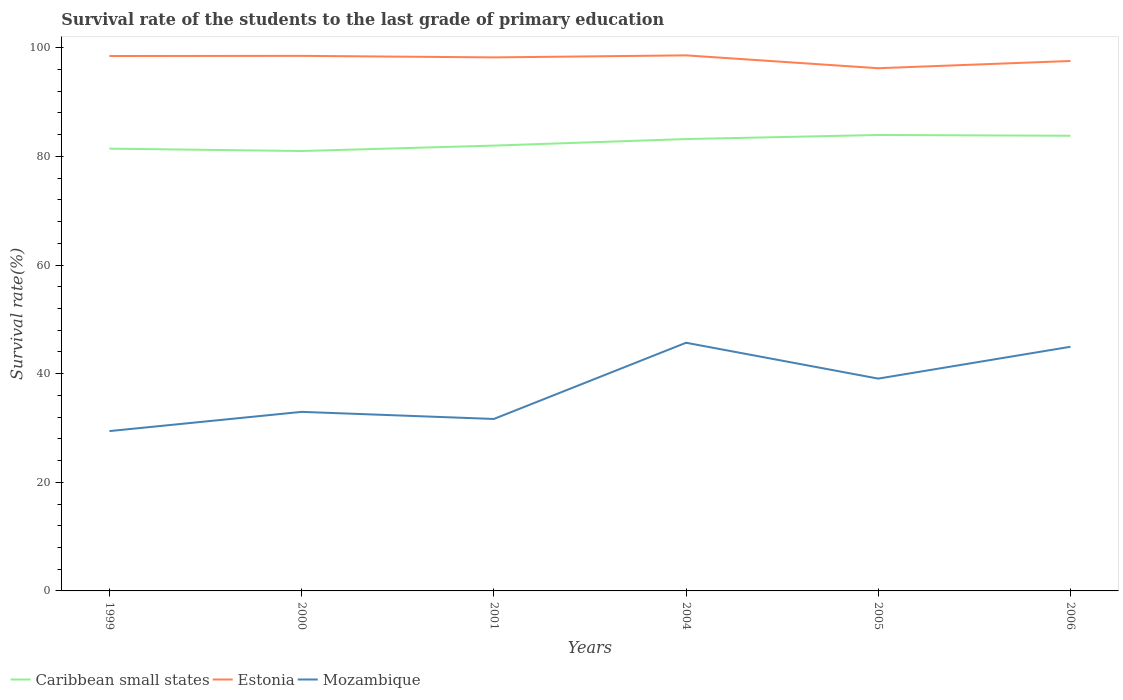How many different coloured lines are there?
Your response must be concise. 3. Is the number of lines equal to the number of legend labels?
Offer a very short reply. Yes. Across all years, what is the maximum survival rate of the students in Mozambique?
Your answer should be very brief. 29.43. In which year was the survival rate of the students in Estonia maximum?
Your answer should be very brief. 2005. What is the total survival rate of the students in Mozambique in the graph?
Your answer should be very brief. -3.54. What is the difference between the highest and the second highest survival rate of the students in Caribbean small states?
Offer a terse response. 2.95. What is the difference between the highest and the lowest survival rate of the students in Estonia?
Your response must be concise. 4. How many years are there in the graph?
Make the answer very short. 6. What is the difference between two consecutive major ticks on the Y-axis?
Your response must be concise. 20. Where does the legend appear in the graph?
Make the answer very short. Bottom left. How are the legend labels stacked?
Keep it short and to the point. Horizontal. What is the title of the graph?
Your answer should be very brief. Survival rate of the students to the last grade of primary education. Does "Turkmenistan" appear as one of the legend labels in the graph?
Your answer should be very brief. No. What is the label or title of the X-axis?
Your answer should be very brief. Years. What is the label or title of the Y-axis?
Your response must be concise. Survival rate(%). What is the Survival rate(%) of Caribbean small states in 1999?
Give a very brief answer. 81.43. What is the Survival rate(%) in Estonia in 1999?
Offer a terse response. 98.48. What is the Survival rate(%) in Mozambique in 1999?
Provide a short and direct response. 29.43. What is the Survival rate(%) in Caribbean small states in 2000?
Offer a very short reply. 80.99. What is the Survival rate(%) in Estonia in 2000?
Your answer should be very brief. 98.51. What is the Survival rate(%) in Mozambique in 2000?
Offer a very short reply. 32.97. What is the Survival rate(%) in Caribbean small states in 2001?
Your response must be concise. 81.99. What is the Survival rate(%) of Estonia in 2001?
Ensure brevity in your answer.  98.23. What is the Survival rate(%) of Mozambique in 2001?
Your response must be concise. 31.66. What is the Survival rate(%) of Caribbean small states in 2004?
Keep it short and to the point. 83.19. What is the Survival rate(%) of Estonia in 2004?
Provide a short and direct response. 98.6. What is the Survival rate(%) in Mozambique in 2004?
Your answer should be very brief. 45.69. What is the Survival rate(%) of Caribbean small states in 2005?
Your answer should be compact. 83.94. What is the Survival rate(%) of Estonia in 2005?
Give a very brief answer. 96.24. What is the Survival rate(%) in Mozambique in 2005?
Provide a succinct answer. 39.09. What is the Survival rate(%) in Caribbean small states in 2006?
Provide a succinct answer. 83.8. What is the Survival rate(%) in Estonia in 2006?
Provide a succinct answer. 97.57. What is the Survival rate(%) of Mozambique in 2006?
Offer a very short reply. 44.95. Across all years, what is the maximum Survival rate(%) of Caribbean small states?
Your answer should be very brief. 83.94. Across all years, what is the maximum Survival rate(%) of Estonia?
Give a very brief answer. 98.6. Across all years, what is the maximum Survival rate(%) in Mozambique?
Keep it short and to the point. 45.69. Across all years, what is the minimum Survival rate(%) in Caribbean small states?
Your response must be concise. 80.99. Across all years, what is the minimum Survival rate(%) in Estonia?
Make the answer very short. 96.24. Across all years, what is the minimum Survival rate(%) in Mozambique?
Ensure brevity in your answer.  29.43. What is the total Survival rate(%) in Caribbean small states in the graph?
Your answer should be very brief. 495.35. What is the total Survival rate(%) of Estonia in the graph?
Your answer should be compact. 587.63. What is the total Survival rate(%) of Mozambique in the graph?
Your answer should be very brief. 223.79. What is the difference between the Survival rate(%) in Caribbean small states in 1999 and that in 2000?
Give a very brief answer. 0.44. What is the difference between the Survival rate(%) of Estonia in 1999 and that in 2000?
Keep it short and to the point. -0.03. What is the difference between the Survival rate(%) in Mozambique in 1999 and that in 2000?
Provide a succinct answer. -3.54. What is the difference between the Survival rate(%) of Caribbean small states in 1999 and that in 2001?
Keep it short and to the point. -0.56. What is the difference between the Survival rate(%) in Estonia in 1999 and that in 2001?
Your answer should be very brief. 0.25. What is the difference between the Survival rate(%) of Mozambique in 1999 and that in 2001?
Offer a very short reply. -2.23. What is the difference between the Survival rate(%) of Caribbean small states in 1999 and that in 2004?
Your response must be concise. -1.76. What is the difference between the Survival rate(%) of Estonia in 1999 and that in 2004?
Offer a very short reply. -0.12. What is the difference between the Survival rate(%) of Mozambique in 1999 and that in 2004?
Offer a terse response. -16.26. What is the difference between the Survival rate(%) of Caribbean small states in 1999 and that in 2005?
Your answer should be compact. -2.51. What is the difference between the Survival rate(%) of Estonia in 1999 and that in 2005?
Make the answer very short. 2.25. What is the difference between the Survival rate(%) of Mozambique in 1999 and that in 2005?
Provide a succinct answer. -9.66. What is the difference between the Survival rate(%) in Caribbean small states in 1999 and that in 2006?
Offer a terse response. -2.37. What is the difference between the Survival rate(%) in Estonia in 1999 and that in 2006?
Offer a very short reply. 0.91. What is the difference between the Survival rate(%) in Mozambique in 1999 and that in 2006?
Your response must be concise. -15.52. What is the difference between the Survival rate(%) in Caribbean small states in 2000 and that in 2001?
Keep it short and to the point. -1. What is the difference between the Survival rate(%) of Estonia in 2000 and that in 2001?
Your answer should be very brief. 0.28. What is the difference between the Survival rate(%) in Mozambique in 2000 and that in 2001?
Your answer should be very brief. 1.31. What is the difference between the Survival rate(%) in Caribbean small states in 2000 and that in 2004?
Offer a terse response. -2.2. What is the difference between the Survival rate(%) in Estonia in 2000 and that in 2004?
Provide a succinct answer. -0.09. What is the difference between the Survival rate(%) in Mozambique in 2000 and that in 2004?
Offer a terse response. -12.72. What is the difference between the Survival rate(%) in Caribbean small states in 2000 and that in 2005?
Keep it short and to the point. -2.95. What is the difference between the Survival rate(%) of Estonia in 2000 and that in 2005?
Your response must be concise. 2.28. What is the difference between the Survival rate(%) of Mozambique in 2000 and that in 2005?
Your answer should be compact. -6.12. What is the difference between the Survival rate(%) of Caribbean small states in 2000 and that in 2006?
Your answer should be compact. -2.81. What is the difference between the Survival rate(%) of Estonia in 2000 and that in 2006?
Make the answer very short. 0.94. What is the difference between the Survival rate(%) in Mozambique in 2000 and that in 2006?
Offer a terse response. -11.98. What is the difference between the Survival rate(%) in Caribbean small states in 2001 and that in 2004?
Your response must be concise. -1.2. What is the difference between the Survival rate(%) in Estonia in 2001 and that in 2004?
Make the answer very short. -0.37. What is the difference between the Survival rate(%) in Mozambique in 2001 and that in 2004?
Provide a short and direct response. -14.03. What is the difference between the Survival rate(%) in Caribbean small states in 2001 and that in 2005?
Give a very brief answer. -1.95. What is the difference between the Survival rate(%) of Estonia in 2001 and that in 2005?
Provide a short and direct response. 1.99. What is the difference between the Survival rate(%) in Mozambique in 2001 and that in 2005?
Offer a terse response. -7.43. What is the difference between the Survival rate(%) of Caribbean small states in 2001 and that in 2006?
Offer a very short reply. -1.81. What is the difference between the Survival rate(%) in Estonia in 2001 and that in 2006?
Offer a terse response. 0.66. What is the difference between the Survival rate(%) in Mozambique in 2001 and that in 2006?
Make the answer very short. -13.29. What is the difference between the Survival rate(%) of Caribbean small states in 2004 and that in 2005?
Provide a short and direct response. -0.75. What is the difference between the Survival rate(%) in Estonia in 2004 and that in 2005?
Make the answer very short. 2.37. What is the difference between the Survival rate(%) in Mozambique in 2004 and that in 2005?
Provide a succinct answer. 6.6. What is the difference between the Survival rate(%) in Caribbean small states in 2004 and that in 2006?
Provide a succinct answer. -0.61. What is the difference between the Survival rate(%) of Estonia in 2004 and that in 2006?
Offer a very short reply. 1.03. What is the difference between the Survival rate(%) of Mozambique in 2004 and that in 2006?
Give a very brief answer. 0.74. What is the difference between the Survival rate(%) of Caribbean small states in 2005 and that in 2006?
Your response must be concise. 0.14. What is the difference between the Survival rate(%) of Estonia in 2005 and that in 2006?
Your answer should be very brief. -1.33. What is the difference between the Survival rate(%) in Mozambique in 2005 and that in 2006?
Offer a very short reply. -5.86. What is the difference between the Survival rate(%) of Caribbean small states in 1999 and the Survival rate(%) of Estonia in 2000?
Your response must be concise. -17.08. What is the difference between the Survival rate(%) of Caribbean small states in 1999 and the Survival rate(%) of Mozambique in 2000?
Give a very brief answer. 48.46. What is the difference between the Survival rate(%) of Estonia in 1999 and the Survival rate(%) of Mozambique in 2000?
Offer a terse response. 65.51. What is the difference between the Survival rate(%) in Caribbean small states in 1999 and the Survival rate(%) in Estonia in 2001?
Make the answer very short. -16.8. What is the difference between the Survival rate(%) in Caribbean small states in 1999 and the Survival rate(%) in Mozambique in 2001?
Provide a short and direct response. 49.77. What is the difference between the Survival rate(%) of Estonia in 1999 and the Survival rate(%) of Mozambique in 2001?
Your answer should be very brief. 66.82. What is the difference between the Survival rate(%) of Caribbean small states in 1999 and the Survival rate(%) of Estonia in 2004?
Your response must be concise. -17.17. What is the difference between the Survival rate(%) of Caribbean small states in 1999 and the Survival rate(%) of Mozambique in 2004?
Provide a short and direct response. 35.74. What is the difference between the Survival rate(%) in Estonia in 1999 and the Survival rate(%) in Mozambique in 2004?
Your answer should be very brief. 52.79. What is the difference between the Survival rate(%) in Caribbean small states in 1999 and the Survival rate(%) in Estonia in 2005?
Provide a succinct answer. -14.81. What is the difference between the Survival rate(%) of Caribbean small states in 1999 and the Survival rate(%) of Mozambique in 2005?
Your answer should be very brief. 42.34. What is the difference between the Survival rate(%) in Estonia in 1999 and the Survival rate(%) in Mozambique in 2005?
Offer a very short reply. 59.39. What is the difference between the Survival rate(%) of Caribbean small states in 1999 and the Survival rate(%) of Estonia in 2006?
Offer a very short reply. -16.14. What is the difference between the Survival rate(%) in Caribbean small states in 1999 and the Survival rate(%) in Mozambique in 2006?
Ensure brevity in your answer.  36.48. What is the difference between the Survival rate(%) of Estonia in 1999 and the Survival rate(%) of Mozambique in 2006?
Your response must be concise. 53.53. What is the difference between the Survival rate(%) of Caribbean small states in 2000 and the Survival rate(%) of Estonia in 2001?
Offer a terse response. -17.24. What is the difference between the Survival rate(%) of Caribbean small states in 2000 and the Survival rate(%) of Mozambique in 2001?
Ensure brevity in your answer.  49.33. What is the difference between the Survival rate(%) of Estonia in 2000 and the Survival rate(%) of Mozambique in 2001?
Offer a very short reply. 66.85. What is the difference between the Survival rate(%) of Caribbean small states in 2000 and the Survival rate(%) of Estonia in 2004?
Provide a short and direct response. -17.61. What is the difference between the Survival rate(%) of Caribbean small states in 2000 and the Survival rate(%) of Mozambique in 2004?
Your answer should be compact. 35.3. What is the difference between the Survival rate(%) in Estonia in 2000 and the Survival rate(%) in Mozambique in 2004?
Make the answer very short. 52.82. What is the difference between the Survival rate(%) of Caribbean small states in 2000 and the Survival rate(%) of Estonia in 2005?
Ensure brevity in your answer.  -15.24. What is the difference between the Survival rate(%) in Caribbean small states in 2000 and the Survival rate(%) in Mozambique in 2005?
Ensure brevity in your answer.  41.9. What is the difference between the Survival rate(%) in Estonia in 2000 and the Survival rate(%) in Mozambique in 2005?
Keep it short and to the point. 59.42. What is the difference between the Survival rate(%) in Caribbean small states in 2000 and the Survival rate(%) in Estonia in 2006?
Give a very brief answer. -16.58. What is the difference between the Survival rate(%) of Caribbean small states in 2000 and the Survival rate(%) of Mozambique in 2006?
Make the answer very short. 36.04. What is the difference between the Survival rate(%) of Estonia in 2000 and the Survival rate(%) of Mozambique in 2006?
Your answer should be very brief. 53.56. What is the difference between the Survival rate(%) of Caribbean small states in 2001 and the Survival rate(%) of Estonia in 2004?
Keep it short and to the point. -16.61. What is the difference between the Survival rate(%) of Caribbean small states in 2001 and the Survival rate(%) of Mozambique in 2004?
Your answer should be compact. 36.3. What is the difference between the Survival rate(%) of Estonia in 2001 and the Survival rate(%) of Mozambique in 2004?
Keep it short and to the point. 52.54. What is the difference between the Survival rate(%) in Caribbean small states in 2001 and the Survival rate(%) in Estonia in 2005?
Provide a short and direct response. -14.25. What is the difference between the Survival rate(%) of Caribbean small states in 2001 and the Survival rate(%) of Mozambique in 2005?
Give a very brief answer. 42.9. What is the difference between the Survival rate(%) in Estonia in 2001 and the Survival rate(%) in Mozambique in 2005?
Make the answer very short. 59.14. What is the difference between the Survival rate(%) in Caribbean small states in 2001 and the Survival rate(%) in Estonia in 2006?
Your answer should be compact. -15.58. What is the difference between the Survival rate(%) of Caribbean small states in 2001 and the Survival rate(%) of Mozambique in 2006?
Your answer should be compact. 37.04. What is the difference between the Survival rate(%) of Estonia in 2001 and the Survival rate(%) of Mozambique in 2006?
Your answer should be very brief. 53.28. What is the difference between the Survival rate(%) in Caribbean small states in 2004 and the Survival rate(%) in Estonia in 2005?
Make the answer very short. -13.04. What is the difference between the Survival rate(%) in Caribbean small states in 2004 and the Survival rate(%) in Mozambique in 2005?
Offer a terse response. 44.1. What is the difference between the Survival rate(%) in Estonia in 2004 and the Survival rate(%) in Mozambique in 2005?
Ensure brevity in your answer.  59.51. What is the difference between the Survival rate(%) of Caribbean small states in 2004 and the Survival rate(%) of Estonia in 2006?
Provide a short and direct response. -14.38. What is the difference between the Survival rate(%) in Caribbean small states in 2004 and the Survival rate(%) in Mozambique in 2006?
Give a very brief answer. 38.24. What is the difference between the Survival rate(%) in Estonia in 2004 and the Survival rate(%) in Mozambique in 2006?
Keep it short and to the point. 53.65. What is the difference between the Survival rate(%) of Caribbean small states in 2005 and the Survival rate(%) of Estonia in 2006?
Your answer should be compact. -13.63. What is the difference between the Survival rate(%) of Caribbean small states in 2005 and the Survival rate(%) of Mozambique in 2006?
Offer a very short reply. 38.99. What is the difference between the Survival rate(%) of Estonia in 2005 and the Survival rate(%) of Mozambique in 2006?
Your response must be concise. 51.29. What is the average Survival rate(%) of Caribbean small states per year?
Offer a very short reply. 82.56. What is the average Survival rate(%) in Estonia per year?
Offer a very short reply. 97.94. What is the average Survival rate(%) in Mozambique per year?
Make the answer very short. 37.3. In the year 1999, what is the difference between the Survival rate(%) of Caribbean small states and Survival rate(%) of Estonia?
Keep it short and to the point. -17.05. In the year 1999, what is the difference between the Survival rate(%) of Caribbean small states and Survival rate(%) of Mozambique?
Keep it short and to the point. 52. In the year 1999, what is the difference between the Survival rate(%) in Estonia and Survival rate(%) in Mozambique?
Your answer should be very brief. 69.05. In the year 2000, what is the difference between the Survival rate(%) in Caribbean small states and Survival rate(%) in Estonia?
Offer a very short reply. -17.52. In the year 2000, what is the difference between the Survival rate(%) in Caribbean small states and Survival rate(%) in Mozambique?
Offer a very short reply. 48.02. In the year 2000, what is the difference between the Survival rate(%) in Estonia and Survival rate(%) in Mozambique?
Provide a short and direct response. 65.54. In the year 2001, what is the difference between the Survival rate(%) in Caribbean small states and Survival rate(%) in Estonia?
Keep it short and to the point. -16.24. In the year 2001, what is the difference between the Survival rate(%) of Caribbean small states and Survival rate(%) of Mozambique?
Offer a very short reply. 50.33. In the year 2001, what is the difference between the Survival rate(%) in Estonia and Survival rate(%) in Mozambique?
Offer a very short reply. 66.57. In the year 2004, what is the difference between the Survival rate(%) in Caribbean small states and Survival rate(%) in Estonia?
Offer a very short reply. -15.41. In the year 2004, what is the difference between the Survival rate(%) in Caribbean small states and Survival rate(%) in Mozambique?
Provide a short and direct response. 37.5. In the year 2004, what is the difference between the Survival rate(%) in Estonia and Survival rate(%) in Mozambique?
Your response must be concise. 52.91. In the year 2005, what is the difference between the Survival rate(%) of Caribbean small states and Survival rate(%) of Estonia?
Your response must be concise. -12.29. In the year 2005, what is the difference between the Survival rate(%) in Caribbean small states and Survival rate(%) in Mozambique?
Your answer should be very brief. 44.85. In the year 2005, what is the difference between the Survival rate(%) in Estonia and Survival rate(%) in Mozambique?
Give a very brief answer. 57.15. In the year 2006, what is the difference between the Survival rate(%) in Caribbean small states and Survival rate(%) in Estonia?
Provide a succinct answer. -13.77. In the year 2006, what is the difference between the Survival rate(%) of Caribbean small states and Survival rate(%) of Mozambique?
Make the answer very short. 38.85. In the year 2006, what is the difference between the Survival rate(%) of Estonia and Survival rate(%) of Mozambique?
Keep it short and to the point. 52.62. What is the ratio of the Survival rate(%) in Caribbean small states in 1999 to that in 2000?
Give a very brief answer. 1.01. What is the ratio of the Survival rate(%) in Mozambique in 1999 to that in 2000?
Ensure brevity in your answer.  0.89. What is the ratio of the Survival rate(%) in Mozambique in 1999 to that in 2001?
Make the answer very short. 0.93. What is the ratio of the Survival rate(%) of Caribbean small states in 1999 to that in 2004?
Your answer should be compact. 0.98. What is the ratio of the Survival rate(%) of Mozambique in 1999 to that in 2004?
Your answer should be very brief. 0.64. What is the ratio of the Survival rate(%) of Caribbean small states in 1999 to that in 2005?
Provide a succinct answer. 0.97. What is the ratio of the Survival rate(%) in Estonia in 1999 to that in 2005?
Offer a terse response. 1.02. What is the ratio of the Survival rate(%) in Mozambique in 1999 to that in 2005?
Keep it short and to the point. 0.75. What is the ratio of the Survival rate(%) of Caribbean small states in 1999 to that in 2006?
Provide a succinct answer. 0.97. What is the ratio of the Survival rate(%) in Estonia in 1999 to that in 2006?
Ensure brevity in your answer.  1.01. What is the ratio of the Survival rate(%) in Mozambique in 1999 to that in 2006?
Give a very brief answer. 0.65. What is the ratio of the Survival rate(%) of Estonia in 2000 to that in 2001?
Provide a short and direct response. 1. What is the ratio of the Survival rate(%) of Mozambique in 2000 to that in 2001?
Make the answer very short. 1.04. What is the ratio of the Survival rate(%) in Caribbean small states in 2000 to that in 2004?
Your answer should be very brief. 0.97. What is the ratio of the Survival rate(%) of Estonia in 2000 to that in 2004?
Offer a very short reply. 1. What is the ratio of the Survival rate(%) of Mozambique in 2000 to that in 2004?
Keep it short and to the point. 0.72. What is the ratio of the Survival rate(%) in Caribbean small states in 2000 to that in 2005?
Your answer should be compact. 0.96. What is the ratio of the Survival rate(%) of Estonia in 2000 to that in 2005?
Ensure brevity in your answer.  1.02. What is the ratio of the Survival rate(%) of Mozambique in 2000 to that in 2005?
Your response must be concise. 0.84. What is the ratio of the Survival rate(%) in Caribbean small states in 2000 to that in 2006?
Your answer should be very brief. 0.97. What is the ratio of the Survival rate(%) in Estonia in 2000 to that in 2006?
Provide a short and direct response. 1.01. What is the ratio of the Survival rate(%) of Mozambique in 2000 to that in 2006?
Your answer should be compact. 0.73. What is the ratio of the Survival rate(%) in Caribbean small states in 2001 to that in 2004?
Make the answer very short. 0.99. What is the ratio of the Survival rate(%) of Estonia in 2001 to that in 2004?
Offer a very short reply. 1. What is the ratio of the Survival rate(%) in Mozambique in 2001 to that in 2004?
Ensure brevity in your answer.  0.69. What is the ratio of the Survival rate(%) in Caribbean small states in 2001 to that in 2005?
Keep it short and to the point. 0.98. What is the ratio of the Survival rate(%) of Estonia in 2001 to that in 2005?
Your answer should be compact. 1.02. What is the ratio of the Survival rate(%) of Mozambique in 2001 to that in 2005?
Offer a very short reply. 0.81. What is the ratio of the Survival rate(%) of Caribbean small states in 2001 to that in 2006?
Keep it short and to the point. 0.98. What is the ratio of the Survival rate(%) in Estonia in 2001 to that in 2006?
Provide a short and direct response. 1.01. What is the ratio of the Survival rate(%) in Mozambique in 2001 to that in 2006?
Your response must be concise. 0.7. What is the ratio of the Survival rate(%) in Caribbean small states in 2004 to that in 2005?
Your response must be concise. 0.99. What is the ratio of the Survival rate(%) in Estonia in 2004 to that in 2005?
Your answer should be very brief. 1.02. What is the ratio of the Survival rate(%) of Mozambique in 2004 to that in 2005?
Make the answer very short. 1.17. What is the ratio of the Survival rate(%) of Estonia in 2004 to that in 2006?
Offer a terse response. 1.01. What is the ratio of the Survival rate(%) of Mozambique in 2004 to that in 2006?
Your answer should be compact. 1.02. What is the ratio of the Survival rate(%) of Caribbean small states in 2005 to that in 2006?
Your answer should be compact. 1. What is the ratio of the Survival rate(%) in Estonia in 2005 to that in 2006?
Keep it short and to the point. 0.99. What is the ratio of the Survival rate(%) of Mozambique in 2005 to that in 2006?
Offer a very short reply. 0.87. What is the difference between the highest and the second highest Survival rate(%) in Caribbean small states?
Give a very brief answer. 0.14. What is the difference between the highest and the second highest Survival rate(%) of Estonia?
Your answer should be very brief. 0.09. What is the difference between the highest and the second highest Survival rate(%) of Mozambique?
Make the answer very short. 0.74. What is the difference between the highest and the lowest Survival rate(%) of Caribbean small states?
Provide a short and direct response. 2.95. What is the difference between the highest and the lowest Survival rate(%) of Estonia?
Your answer should be very brief. 2.37. What is the difference between the highest and the lowest Survival rate(%) of Mozambique?
Your response must be concise. 16.26. 